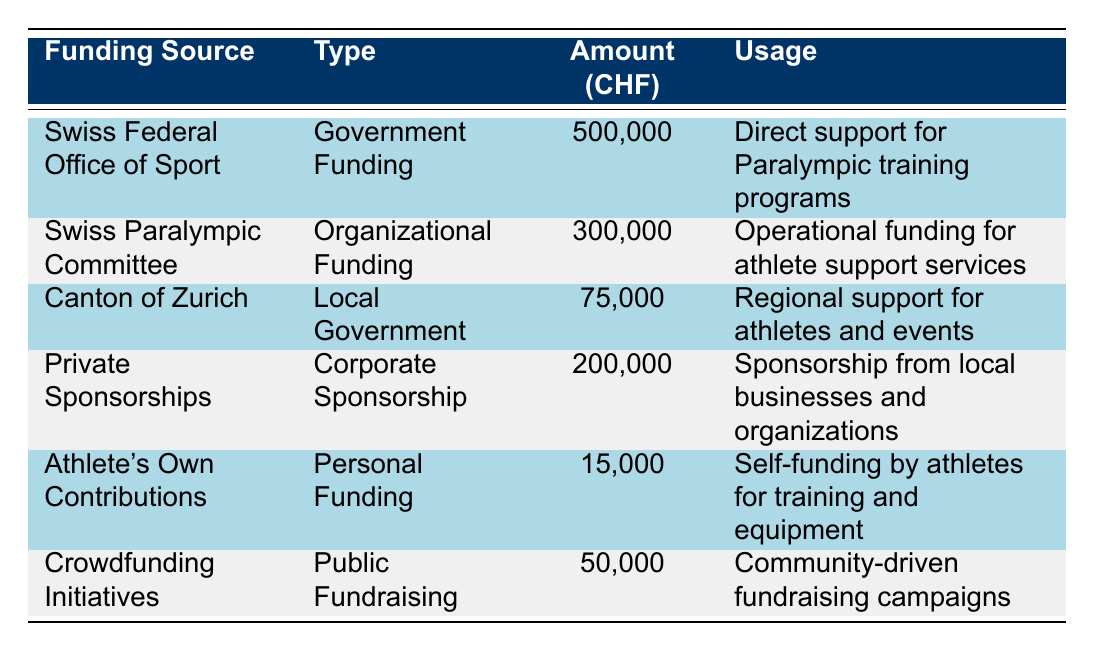What is the total funding from the Swiss Federal Office of Sport? According to the table, the Swiss Federal Office of Sport provides 500,000 CHF in funding.
Answer: 500,000 What is the sum of the funding amounts from the Swiss Paralympic Committee and Private Sponsorships? The Swiss Paralympic Committee contributes 300,000 CHF and Private Sponsorships amount to 200,000 CHF. Summing these gives 300,000 + 200,000 = 500,000 CHF.
Answer: 500,000 Is the funding from the Canton of Zurich more or less than 100,000 CHF? The Canton of Zurich provides 75,000 CHF, which is less than 100,000 CHF.
Answer: Less Does Athlete's Own Contributions exceed 20,000 CHF? Athlete's Own Contributions amount to 15,000 CHF, which does not exceed 20,000 CHF.
Answer: No What is the total amount of funding from all sources listed? To find the total, we add all funding amounts: 500,000 + 300,000 + 75,000 + 200,000 + 15,000 + 50,000 = 1,140,000 CHF.
Answer: 1,140,000 Are all funding sources types classified as either Government Funding or Corporate Sponsorship? The funding sources include types such as Government Funding, Organizational Funding, Local Government, Corporate Sponsorship, Personal Funding, and Public Fundraising, indicating not all are classified as just Government or Corporate.
Answer: No Which funding source has the least amount of financial support? Among the listed sources, Athlete's Own Contributions has the least financial support at 15,000 CHF.
Answer: Athlete's Own Contributions If you combine the funding from Private Sponsorships and Crowdfunding Initiatives, what would that total be? Private Sponsorships provide 200,000 CHF, and Crowdfunding Initiatives provide 50,000 CHF. Adding these gives 200,000 + 50,000 = 250,000 CHF.
Answer: 250,000 Is the funding amount from the Swiss Paralympic Committee greater than the sum of the amounts from the Canton of Zurich and Crowdfunding Initiatives? Swiss Paralympic Committee funding is 300,000 CHF. The sum of the Canton of Zurich (75,000 CHF) and Crowdfunding Initiatives (50,000 CHF) is 125,000 CHF. Since 300,000 > 125,000, the statement is true.
Answer: Yes 